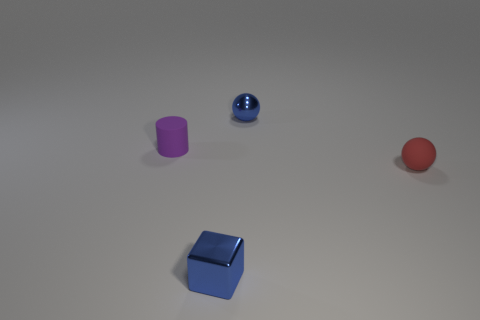Add 2 small blue metallic blocks. How many objects exist? 6 Subtract all cylinders. How many objects are left? 3 Subtract 0 red cubes. How many objects are left? 4 Subtract all red objects. Subtract all red balls. How many objects are left? 2 Add 2 tiny purple cylinders. How many tiny purple cylinders are left? 3 Add 1 tiny brown matte cylinders. How many tiny brown matte cylinders exist? 1 